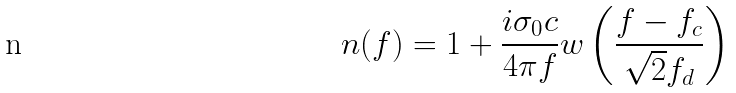<formula> <loc_0><loc_0><loc_500><loc_500>n ( f ) = 1 + \frac { i \sigma _ { 0 } c } { 4 \pi f } w \left ( \frac { f - f _ { c } } { \sqrt { 2 } f _ { d } } \right )</formula> 